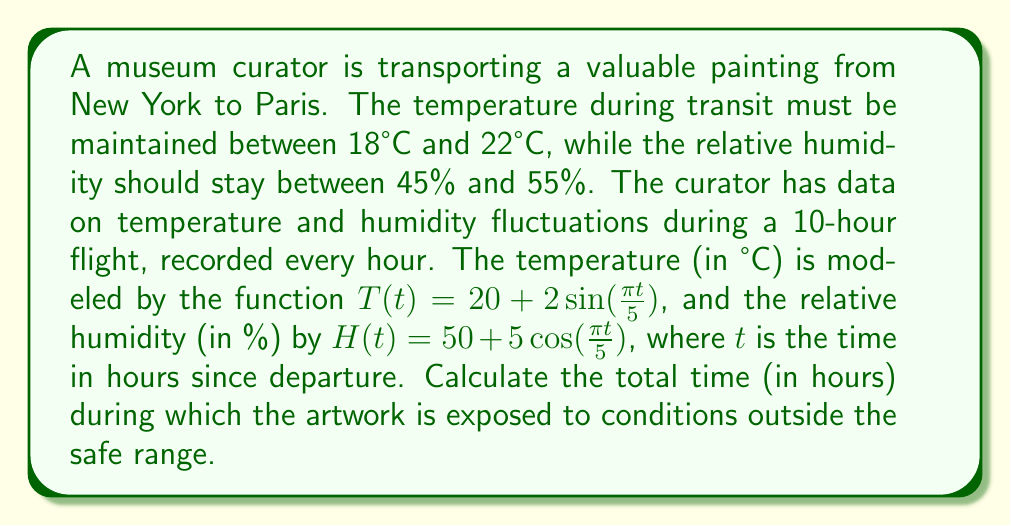Help me with this question. Let's approach this step-by-step:

1) First, we need to find when the temperature is outside the safe range (18°C to 22°C).
   The temperature function is $T(t) = 20 + 2\sin(\frac{\pi t}{5})$
   
   - Temperature is too high when: $20 + 2\sin(\frac{\pi t}{5}) > 22$
     $\sin(\frac{\pi t}{5}) > 1$ (which never occurs as $\sin$ is bounded by -1 and 1)
   
   - Temperature is too low when: $20 + 2\sin(\frac{\pi t}{5}) < 18$
     $\sin(\frac{\pi t}{5}) < -1$ (which also never occurs)

   So, the temperature always remains within the safe range.

2) Now, let's check when the humidity is outside the safe range (45% to 55%).
   The humidity function is $H(t) = 50 + 5\cos(\frac{\pi t}{5})$
   
   - Humidity is too high when: $50 + 5\cos(\frac{\pi t}{5}) > 55$
     $\cos(\frac{\pi t}{5}) > 1$ (which never occurs as $\cos$ is bounded by -1 and 1)
   
   - Humidity is too low when: $50 + 5\cos(\frac{\pi t}{5}) < 45$
     $\cos(\frac{\pi t}{5}) < -1$ (which also never occurs)

   So, the humidity also always remains within the safe range.

3) Since both temperature and humidity remain within their safe ranges throughout the 10-hour flight, the total time during which the artwork is exposed to conditions outside the safe range is 0 hours.
Answer: 0 hours 